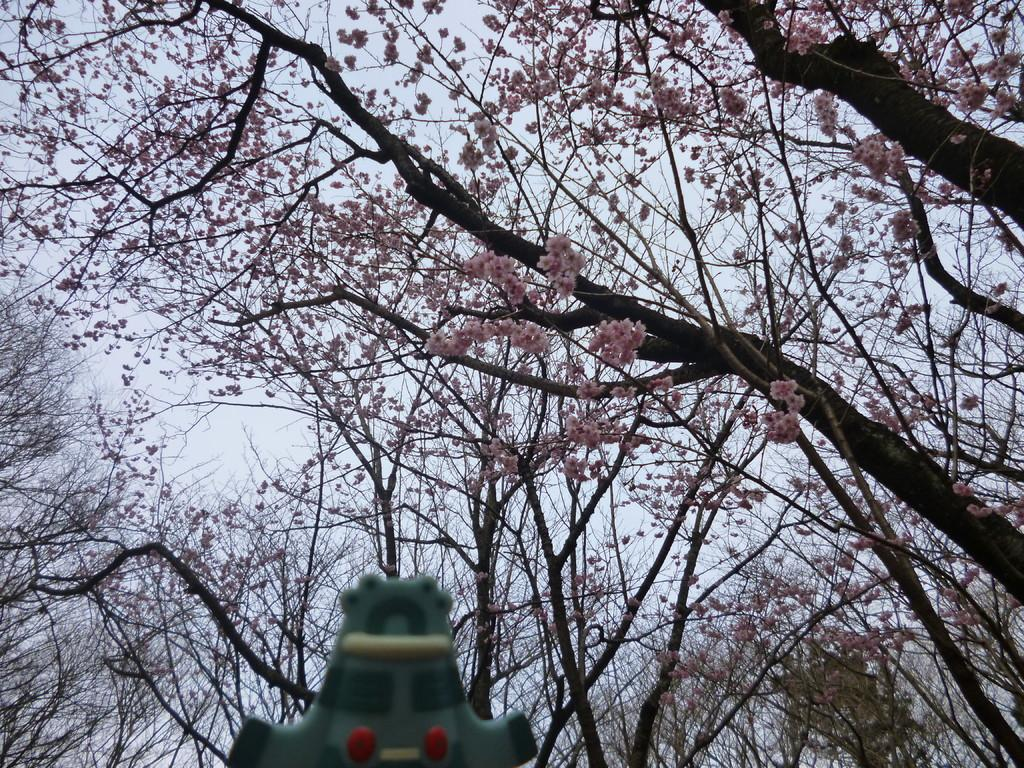What type of vegetation can be seen in the image? There are trees in the image. What color is the green color object in the image? The green color object in the image is green. What part of the natural environment is visible in the image? The sky is visible in the image. Can you tell me how many toes are visible on the person in the image? There is no person present in the image, so it is not possible to determine how many toes might be visible. 